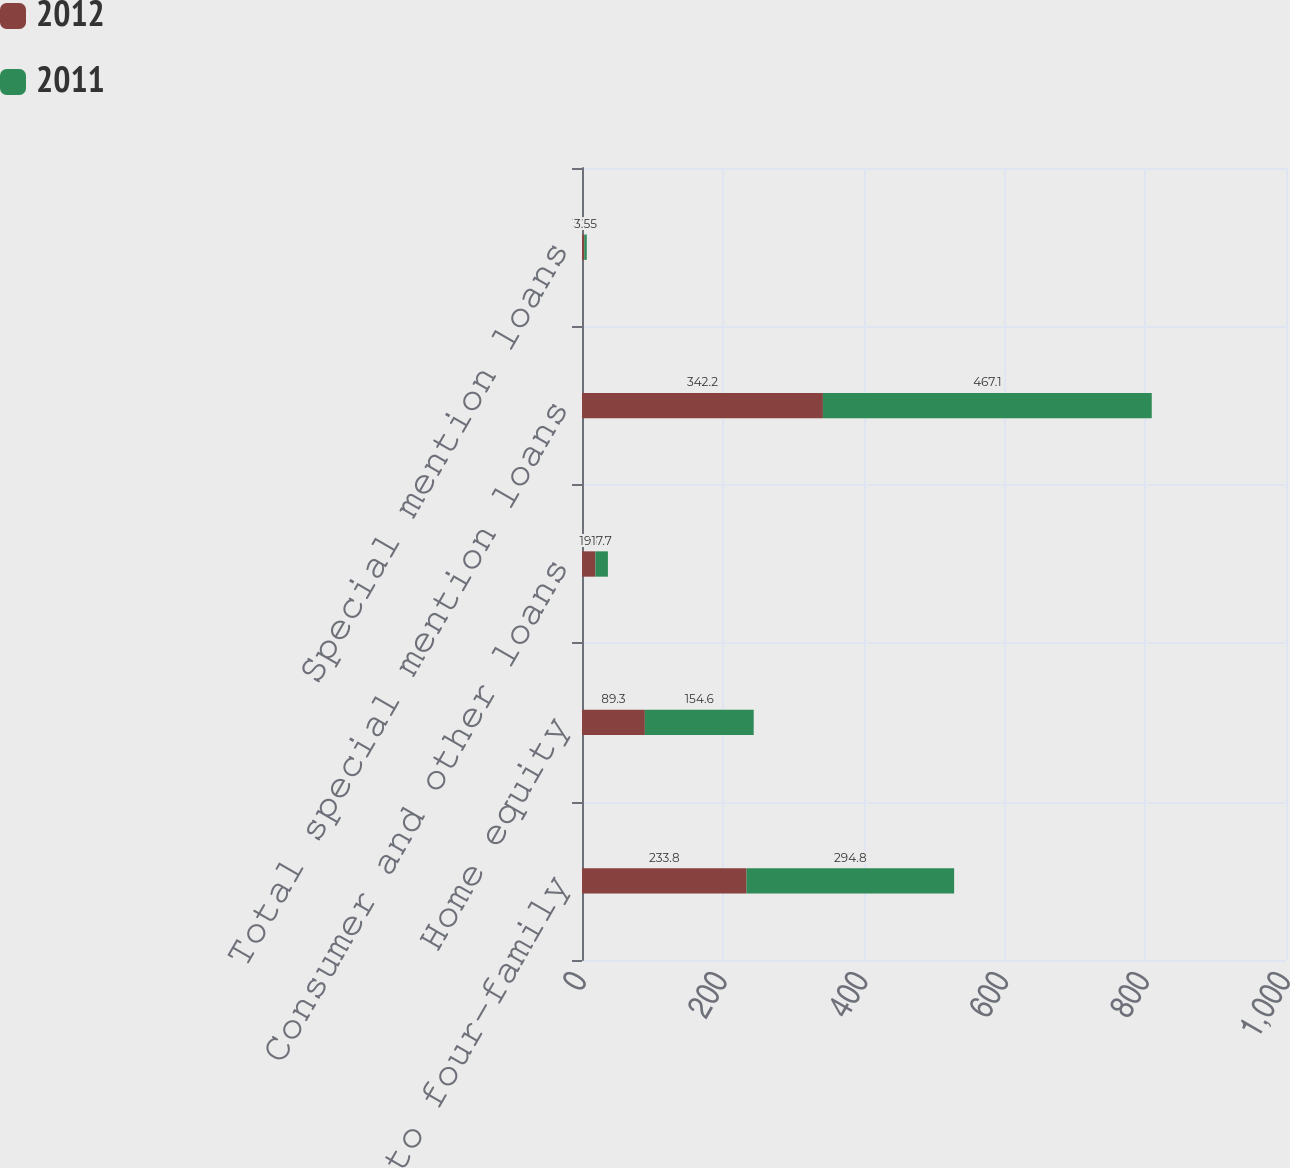Convert chart. <chart><loc_0><loc_0><loc_500><loc_500><stacked_bar_chart><ecel><fcel>One- to four-family<fcel>Home equity<fcel>Consumer and other loans<fcel>Total special mention loans<fcel>Special mention loans<nl><fcel>2012<fcel>233.8<fcel>89.3<fcel>19.1<fcel>342.2<fcel>3.23<nl><fcel>2011<fcel>294.8<fcel>154.6<fcel>17.7<fcel>467.1<fcel>3.55<nl></chart> 